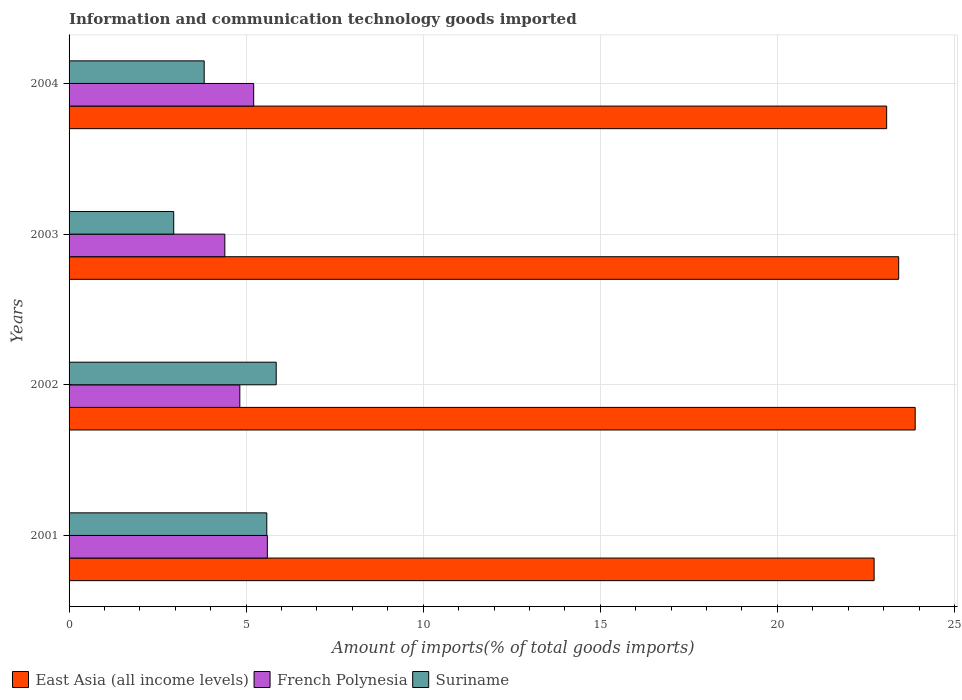How many groups of bars are there?
Your answer should be compact. 4. Are the number of bars per tick equal to the number of legend labels?
Provide a succinct answer. Yes. Are the number of bars on each tick of the Y-axis equal?
Your answer should be very brief. Yes. How many bars are there on the 1st tick from the bottom?
Ensure brevity in your answer.  3. What is the label of the 4th group of bars from the top?
Ensure brevity in your answer.  2001. In how many cases, is the number of bars for a given year not equal to the number of legend labels?
Your answer should be very brief. 0. What is the amount of goods imported in East Asia (all income levels) in 2002?
Provide a short and direct response. 23.89. Across all years, what is the maximum amount of goods imported in Suriname?
Provide a succinct answer. 5.85. Across all years, what is the minimum amount of goods imported in Suriname?
Offer a terse response. 2.95. In which year was the amount of goods imported in French Polynesia maximum?
Ensure brevity in your answer.  2001. What is the total amount of goods imported in French Polynesia in the graph?
Give a very brief answer. 20.03. What is the difference between the amount of goods imported in French Polynesia in 2003 and that in 2004?
Give a very brief answer. -0.81. What is the difference between the amount of goods imported in French Polynesia in 2001 and the amount of goods imported in Suriname in 2003?
Provide a short and direct response. 2.64. What is the average amount of goods imported in French Polynesia per year?
Provide a short and direct response. 5.01. In the year 2001, what is the difference between the amount of goods imported in French Polynesia and amount of goods imported in Suriname?
Offer a terse response. 0.02. What is the ratio of the amount of goods imported in Suriname in 2002 to that in 2004?
Give a very brief answer. 1.53. Is the difference between the amount of goods imported in French Polynesia in 2001 and 2004 greater than the difference between the amount of goods imported in Suriname in 2001 and 2004?
Provide a succinct answer. No. What is the difference between the highest and the second highest amount of goods imported in East Asia (all income levels)?
Your answer should be compact. 0.47. What is the difference between the highest and the lowest amount of goods imported in Suriname?
Ensure brevity in your answer.  2.89. In how many years, is the amount of goods imported in French Polynesia greater than the average amount of goods imported in French Polynesia taken over all years?
Offer a terse response. 2. Is the sum of the amount of goods imported in French Polynesia in 2001 and 2003 greater than the maximum amount of goods imported in Suriname across all years?
Provide a short and direct response. Yes. What does the 1st bar from the top in 2001 represents?
Offer a very short reply. Suriname. What does the 1st bar from the bottom in 2003 represents?
Provide a succinct answer. East Asia (all income levels). Are all the bars in the graph horizontal?
Your response must be concise. Yes. How many years are there in the graph?
Give a very brief answer. 4. What is the difference between two consecutive major ticks on the X-axis?
Provide a succinct answer. 5. Does the graph contain any zero values?
Offer a terse response. No. Where does the legend appear in the graph?
Give a very brief answer. Bottom left. How many legend labels are there?
Your answer should be very brief. 3. What is the title of the graph?
Keep it short and to the point. Information and communication technology goods imported. What is the label or title of the X-axis?
Make the answer very short. Amount of imports(% of total goods imports). What is the Amount of imports(% of total goods imports) of East Asia (all income levels) in 2001?
Keep it short and to the point. 22.73. What is the Amount of imports(% of total goods imports) in French Polynesia in 2001?
Offer a very short reply. 5.6. What is the Amount of imports(% of total goods imports) of Suriname in 2001?
Provide a succinct answer. 5.58. What is the Amount of imports(% of total goods imports) in East Asia (all income levels) in 2002?
Your answer should be very brief. 23.89. What is the Amount of imports(% of total goods imports) of French Polynesia in 2002?
Provide a short and direct response. 4.82. What is the Amount of imports(% of total goods imports) in Suriname in 2002?
Your answer should be very brief. 5.85. What is the Amount of imports(% of total goods imports) in East Asia (all income levels) in 2003?
Your answer should be very brief. 23.42. What is the Amount of imports(% of total goods imports) of French Polynesia in 2003?
Offer a terse response. 4.4. What is the Amount of imports(% of total goods imports) in Suriname in 2003?
Provide a succinct answer. 2.95. What is the Amount of imports(% of total goods imports) in East Asia (all income levels) in 2004?
Ensure brevity in your answer.  23.09. What is the Amount of imports(% of total goods imports) in French Polynesia in 2004?
Ensure brevity in your answer.  5.21. What is the Amount of imports(% of total goods imports) in Suriname in 2004?
Provide a succinct answer. 3.81. Across all years, what is the maximum Amount of imports(% of total goods imports) of East Asia (all income levels)?
Offer a very short reply. 23.89. Across all years, what is the maximum Amount of imports(% of total goods imports) of French Polynesia?
Give a very brief answer. 5.6. Across all years, what is the maximum Amount of imports(% of total goods imports) in Suriname?
Keep it short and to the point. 5.85. Across all years, what is the minimum Amount of imports(% of total goods imports) in East Asia (all income levels)?
Your answer should be very brief. 22.73. Across all years, what is the minimum Amount of imports(% of total goods imports) of French Polynesia?
Keep it short and to the point. 4.4. Across all years, what is the minimum Amount of imports(% of total goods imports) in Suriname?
Ensure brevity in your answer.  2.95. What is the total Amount of imports(% of total goods imports) in East Asia (all income levels) in the graph?
Offer a very short reply. 93.13. What is the total Amount of imports(% of total goods imports) in French Polynesia in the graph?
Provide a succinct answer. 20.03. What is the total Amount of imports(% of total goods imports) of Suriname in the graph?
Provide a succinct answer. 18.2. What is the difference between the Amount of imports(% of total goods imports) of East Asia (all income levels) in 2001 and that in 2002?
Your answer should be compact. -1.16. What is the difference between the Amount of imports(% of total goods imports) in French Polynesia in 2001 and that in 2002?
Your answer should be very brief. 0.78. What is the difference between the Amount of imports(% of total goods imports) in Suriname in 2001 and that in 2002?
Keep it short and to the point. -0.27. What is the difference between the Amount of imports(% of total goods imports) in East Asia (all income levels) in 2001 and that in 2003?
Your response must be concise. -0.69. What is the difference between the Amount of imports(% of total goods imports) of French Polynesia in 2001 and that in 2003?
Make the answer very short. 1.2. What is the difference between the Amount of imports(% of total goods imports) of Suriname in 2001 and that in 2003?
Keep it short and to the point. 2.63. What is the difference between the Amount of imports(% of total goods imports) in East Asia (all income levels) in 2001 and that in 2004?
Make the answer very short. -0.35. What is the difference between the Amount of imports(% of total goods imports) in French Polynesia in 2001 and that in 2004?
Offer a very short reply. 0.39. What is the difference between the Amount of imports(% of total goods imports) of Suriname in 2001 and that in 2004?
Make the answer very short. 1.77. What is the difference between the Amount of imports(% of total goods imports) of East Asia (all income levels) in 2002 and that in 2003?
Provide a succinct answer. 0.47. What is the difference between the Amount of imports(% of total goods imports) of French Polynesia in 2002 and that in 2003?
Give a very brief answer. 0.42. What is the difference between the Amount of imports(% of total goods imports) in Suriname in 2002 and that in 2003?
Your answer should be very brief. 2.89. What is the difference between the Amount of imports(% of total goods imports) of East Asia (all income levels) in 2002 and that in 2004?
Make the answer very short. 0.81. What is the difference between the Amount of imports(% of total goods imports) of French Polynesia in 2002 and that in 2004?
Give a very brief answer. -0.39. What is the difference between the Amount of imports(% of total goods imports) of Suriname in 2002 and that in 2004?
Keep it short and to the point. 2.03. What is the difference between the Amount of imports(% of total goods imports) in East Asia (all income levels) in 2003 and that in 2004?
Give a very brief answer. 0.34. What is the difference between the Amount of imports(% of total goods imports) of French Polynesia in 2003 and that in 2004?
Make the answer very short. -0.81. What is the difference between the Amount of imports(% of total goods imports) in Suriname in 2003 and that in 2004?
Your response must be concise. -0.86. What is the difference between the Amount of imports(% of total goods imports) in East Asia (all income levels) in 2001 and the Amount of imports(% of total goods imports) in French Polynesia in 2002?
Offer a terse response. 17.91. What is the difference between the Amount of imports(% of total goods imports) of East Asia (all income levels) in 2001 and the Amount of imports(% of total goods imports) of Suriname in 2002?
Offer a very short reply. 16.88. What is the difference between the Amount of imports(% of total goods imports) of French Polynesia in 2001 and the Amount of imports(% of total goods imports) of Suriname in 2002?
Ensure brevity in your answer.  -0.25. What is the difference between the Amount of imports(% of total goods imports) of East Asia (all income levels) in 2001 and the Amount of imports(% of total goods imports) of French Polynesia in 2003?
Provide a succinct answer. 18.33. What is the difference between the Amount of imports(% of total goods imports) in East Asia (all income levels) in 2001 and the Amount of imports(% of total goods imports) in Suriname in 2003?
Ensure brevity in your answer.  19.78. What is the difference between the Amount of imports(% of total goods imports) of French Polynesia in 2001 and the Amount of imports(% of total goods imports) of Suriname in 2003?
Give a very brief answer. 2.64. What is the difference between the Amount of imports(% of total goods imports) of East Asia (all income levels) in 2001 and the Amount of imports(% of total goods imports) of French Polynesia in 2004?
Make the answer very short. 17.52. What is the difference between the Amount of imports(% of total goods imports) of East Asia (all income levels) in 2001 and the Amount of imports(% of total goods imports) of Suriname in 2004?
Provide a succinct answer. 18.92. What is the difference between the Amount of imports(% of total goods imports) in French Polynesia in 2001 and the Amount of imports(% of total goods imports) in Suriname in 2004?
Provide a succinct answer. 1.78. What is the difference between the Amount of imports(% of total goods imports) of East Asia (all income levels) in 2002 and the Amount of imports(% of total goods imports) of French Polynesia in 2003?
Ensure brevity in your answer.  19.49. What is the difference between the Amount of imports(% of total goods imports) of East Asia (all income levels) in 2002 and the Amount of imports(% of total goods imports) of Suriname in 2003?
Your answer should be very brief. 20.94. What is the difference between the Amount of imports(% of total goods imports) of French Polynesia in 2002 and the Amount of imports(% of total goods imports) of Suriname in 2003?
Your answer should be very brief. 1.87. What is the difference between the Amount of imports(% of total goods imports) in East Asia (all income levels) in 2002 and the Amount of imports(% of total goods imports) in French Polynesia in 2004?
Give a very brief answer. 18.68. What is the difference between the Amount of imports(% of total goods imports) in East Asia (all income levels) in 2002 and the Amount of imports(% of total goods imports) in Suriname in 2004?
Your response must be concise. 20.08. What is the difference between the Amount of imports(% of total goods imports) of French Polynesia in 2002 and the Amount of imports(% of total goods imports) of Suriname in 2004?
Offer a terse response. 1.01. What is the difference between the Amount of imports(% of total goods imports) of East Asia (all income levels) in 2003 and the Amount of imports(% of total goods imports) of French Polynesia in 2004?
Give a very brief answer. 18.21. What is the difference between the Amount of imports(% of total goods imports) of East Asia (all income levels) in 2003 and the Amount of imports(% of total goods imports) of Suriname in 2004?
Provide a succinct answer. 19.61. What is the difference between the Amount of imports(% of total goods imports) of French Polynesia in 2003 and the Amount of imports(% of total goods imports) of Suriname in 2004?
Provide a succinct answer. 0.58. What is the average Amount of imports(% of total goods imports) of East Asia (all income levels) per year?
Your answer should be compact. 23.28. What is the average Amount of imports(% of total goods imports) in French Polynesia per year?
Provide a succinct answer. 5.01. What is the average Amount of imports(% of total goods imports) of Suriname per year?
Your answer should be very brief. 4.55. In the year 2001, what is the difference between the Amount of imports(% of total goods imports) in East Asia (all income levels) and Amount of imports(% of total goods imports) in French Polynesia?
Your answer should be compact. 17.13. In the year 2001, what is the difference between the Amount of imports(% of total goods imports) in East Asia (all income levels) and Amount of imports(% of total goods imports) in Suriname?
Your response must be concise. 17.15. In the year 2001, what is the difference between the Amount of imports(% of total goods imports) in French Polynesia and Amount of imports(% of total goods imports) in Suriname?
Your answer should be very brief. 0.02. In the year 2002, what is the difference between the Amount of imports(% of total goods imports) in East Asia (all income levels) and Amount of imports(% of total goods imports) in French Polynesia?
Your response must be concise. 19.07. In the year 2002, what is the difference between the Amount of imports(% of total goods imports) of East Asia (all income levels) and Amount of imports(% of total goods imports) of Suriname?
Offer a very short reply. 18.04. In the year 2002, what is the difference between the Amount of imports(% of total goods imports) in French Polynesia and Amount of imports(% of total goods imports) in Suriname?
Provide a short and direct response. -1.03. In the year 2003, what is the difference between the Amount of imports(% of total goods imports) of East Asia (all income levels) and Amount of imports(% of total goods imports) of French Polynesia?
Ensure brevity in your answer.  19.03. In the year 2003, what is the difference between the Amount of imports(% of total goods imports) of East Asia (all income levels) and Amount of imports(% of total goods imports) of Suriname?
Offer a terse response. 20.47. In the year 2003, what is the difference between the Amount of imports(% of total goods imports) of French Polynesia and Amount of imports(% of total goods imports) of Suriname?
Provide a short and direct response. 1.44. In the year 2004, what is the difference between the Amount of imports(% of total goods imports) in East Asia (all income levels) and Amount of imports(% of total goods imports) in French Polynesia?
Keep it short and to the point. 17.87. In the year 2004, what is the difference between the Amount of imports(% of total goods imports) of East Asia (all income levels) and Amount of imports(% of total goods imports) of Suriname?
Make the answer very short. 19.27. In the year 2004, what is the difference between the Amount of imports(% of total goods imports) in French Polynesia and Amount of imports(% of total goods imports) in Suriname?
Ensure brevity in your answer.  1.4. What is the ratio of the Amount of imports(% of total goods imports) of East Asia (all income levels) in 2001 to that in 2002?
Provide a succinct answer. 0.95. What is the ratio of the Amount of imports(% of total goods imports) in French Polynesia in 2001 to that in 2002?
Make the answer very short. 1.16. What is the ratio of the Amount of imports(% of total goods imports) in Suriname in 2001 to that in 2002?
Ensure brevity in your answer.  0.95. What is the ratio of the Amount of imports(% of total goods imports) in East Asia (all income levels) in 2001 to that in 2003?
Offer a terse response. 0.97. What is the ratio of the Amount of imports(% of total goods imports) of French Polynesia in 2001 to that in 2003?
Your answer should be compact. 1.27. What is the ratio of the Amount of imports(% of total goods imports) in Suriname in 2001 to that in 2003?
Your answer should be very brief. 1.89. What is the ratio of the Amount of imports(% of total goods imports) in East Asia (all income levels) in 2001 to that in 2004?
Give a very brief answer. 0.98. What is the ratio of the Amount of imports(% of total goods imports) of French Polynesia in 2001 to that in 2004?
Give a very brief answer. 1.07. What is the ratio of the Amount of imports(% of total goods imports) of Suriname in 2001 to that in 2004?
Your answer should be compact. 1.46. What is the ratio of the Amount of imports(% of total goods imports) in East Asia (all income levels) in 2002 to that in 2003?
Your answer should be very brief. 1.02. What is the ratio of the Amount of imports(% of total goods imports) in French Polynesia in 2002 to that in 2003?
Ensure brevity in your answer.  1.1. What is the ratio of the Amount of imports(% of total goods imports) of Suriname in 2002 to that in 2003?
Your answer should be very brief. 1.98. What is the ratio of the Amount of imports(% of total goods imports) in East Asia (all income levels) in 2002 to that in 2004?
Your answer should be compact. 1.03. What is the ratio of the Amount of imports(% of total goods imports) in French Polynesia in 2002 to that in 2004?
Offer a terse response. 0.92. What is the ratio of the Amount of imports(% of total goods imports) of Suriname in 2002 to that in 2004?
Your response must be concise. 1.53. What is the ratio of the Amount of imports(% of total goods imports) of East Asia (all income levels) in 2003 to that in 2004?
Offer a terse response. 1.01. What is the ratio of the Amount of imports(% of total goods imports) in French Polynesia in 2003 to that in 2004?
Your answer should be compact. 0.84. What is the ratio of the Amount of imports(% of total goods imports) of Suriname in 2003 to that in 2004?
Keep it short and to the point. 0.77. What is the difference between the highest and the second highest Amount of imports(% of total goods imports) of East Asia (all income levels)?
Your answer should be compact. 0.47. What is the difference between the highest and the second highest Amount of imports(% of total goods imports) of French Polynesia?
Your answer should be very brief. 0.39. What is the difference between the highest and the second highest Amount of imports(% of total goods imports) of Suriname?
Make the answer very short. 0.27. What is the difference between the highest and the lowest Amount of imports(% of total goods imports) of East Asia (all income levels)?
Ensure brevity in your answer.  1.16. What is the difference between the highest and the lowest Amount of imports(% of total goods imports) of French Polynesia?
Your response must be concise. 1.2. What is the difference between the highest and the lowest Amount of imports(% of total goods imports) of Suriname?
Your answer should be very brief. 2.89. 